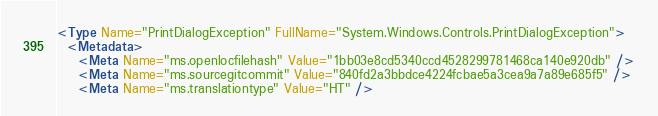Convert code to text. <code><loc_0><loc_0><loc_500><loc_500><_XML_><Type Name="PrintDialogException" FullName="System.Windows.Controls.PrintDialogException">
  <Metadata>
    <Meta Name="ms.openlocfilehash" Value="1bb03e8cd5340ccd4528299781468ca140e920db" />
    <Meta Name="ms.sourcegitcommit" Value="840fd2a3bbdce4224fcbae5a3cea9a7a89e685f5" />
    <Meta Name="ms.translationtype" Value="HT" /></code> 